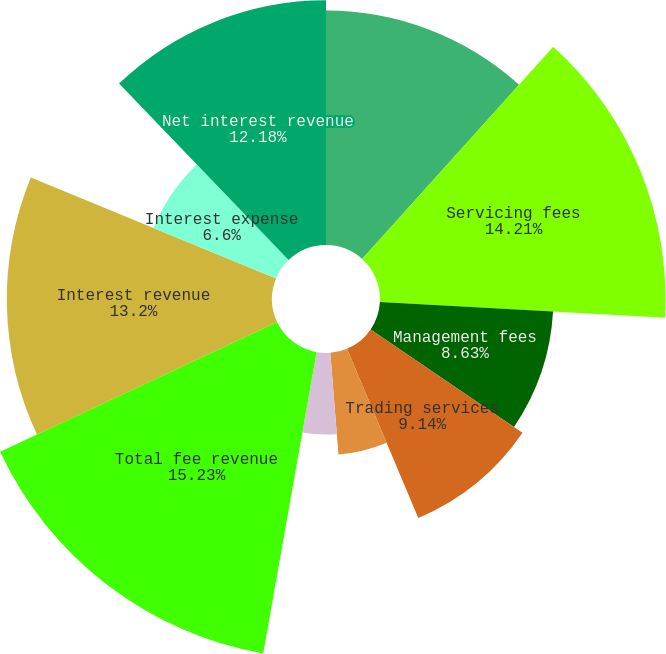Convert chart. <chart><loc_0><loc_0><loc_500><loc_500><pie_chart><fcel>Years ended December 31<fcel>Servicing fees<fcel>Management fees<fcel>Trading services<fcel>Securities finance<fcel>Processing fees and other<fcel>Total fee revenue<fcel>Interest revenue<fcel>Interest expense<fcel>Net interest revenue<nl><fcel>11.67%<fcel>14.21%<fcel>8.63%<fcel>9.14%<fcel>5.08%<fcel>4.06%<fcel>15.23%<fcel>13.2%<fcel>6.6%<fcel>12.18%<nl></chart> 